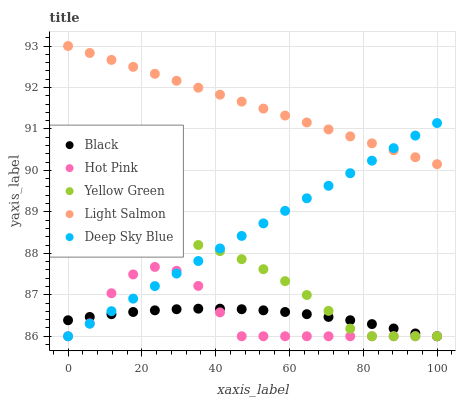Does Hot Pink have the minimum area under the curve?
Answer yes or no. Yes. Does Light Salmon have the maximum area under the curve?
Answer yes or no. Yes. Does Black have the minimum area under the curve?
Answer yes or no. No. Does Black have the maximum area under the curve?
Answer yes or no. No. Is Deep Sky Blue the smoothest?
Answer yes or no. Yes. Is Hot Pink the roughest?
Answer yes or no. Yes. Is Black the smoothest?
Answer yes or no. No. Is Black the roughest?
Answer yes or no. No. Does Hot Pink have the lowest value?
Answer yes or no. Yes. Does Light Salmon have the highest value?
Answer yes or no. Yes. Does Hot Pink have the highest value?
Answer yes or no. No. Is Black less than Light Salmon?
Answer yes or no. Yes. Is Light Salmon greater than Hot Pink?
Answer yes or no. Yes. Does Hot Pink intersect Black?
Answer yes or no. Yes. Is Hot Pink less than Black?
Answer yes or no. No. Is Hot Pink greater than Black?
Answer yes or no. No. Does Black intersect Light Salmon?
Answer yes or no. No. 